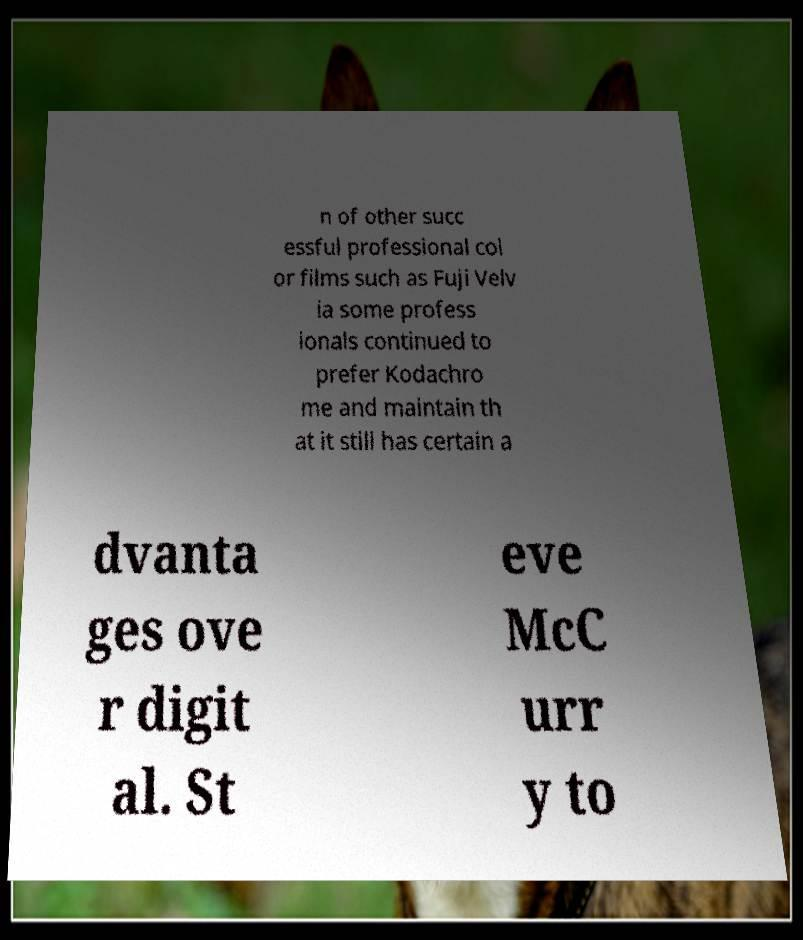I need the written content from this picture converted into text. Can you do that? n of other succ essful professional col or films such as Fuji Velv ia some profess ionals continued to prefer Kodachro me and maintain th at it still has certain a dvanta ges ove r digit al. St eve McC urr y to 